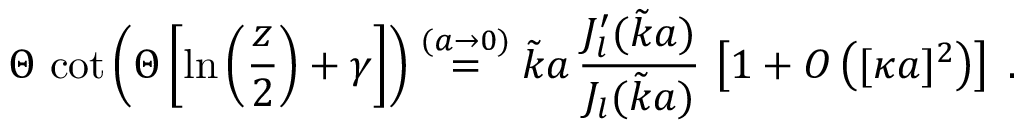Convert formula to latex. <formula><loc_0><loc_0><loc_500><loc_500>\Theta \, \cot \left ( \Theta \left [ \ln \left ( \frac { z } { 2 } \right ) + \gamma \right ] \right ) \stackrel { ( a \rightarrow 0 ) } { = } \tilde { k } a \, \frac { J _ { l } ^ { \prime } ( \tilde { k } a ) } { J _ { l } ( \tilde { k } a ) } \, \left [ 1 + O \left ( [ \kappa a ] ^ { 2 } \right ) \right ] \, .</formula> 